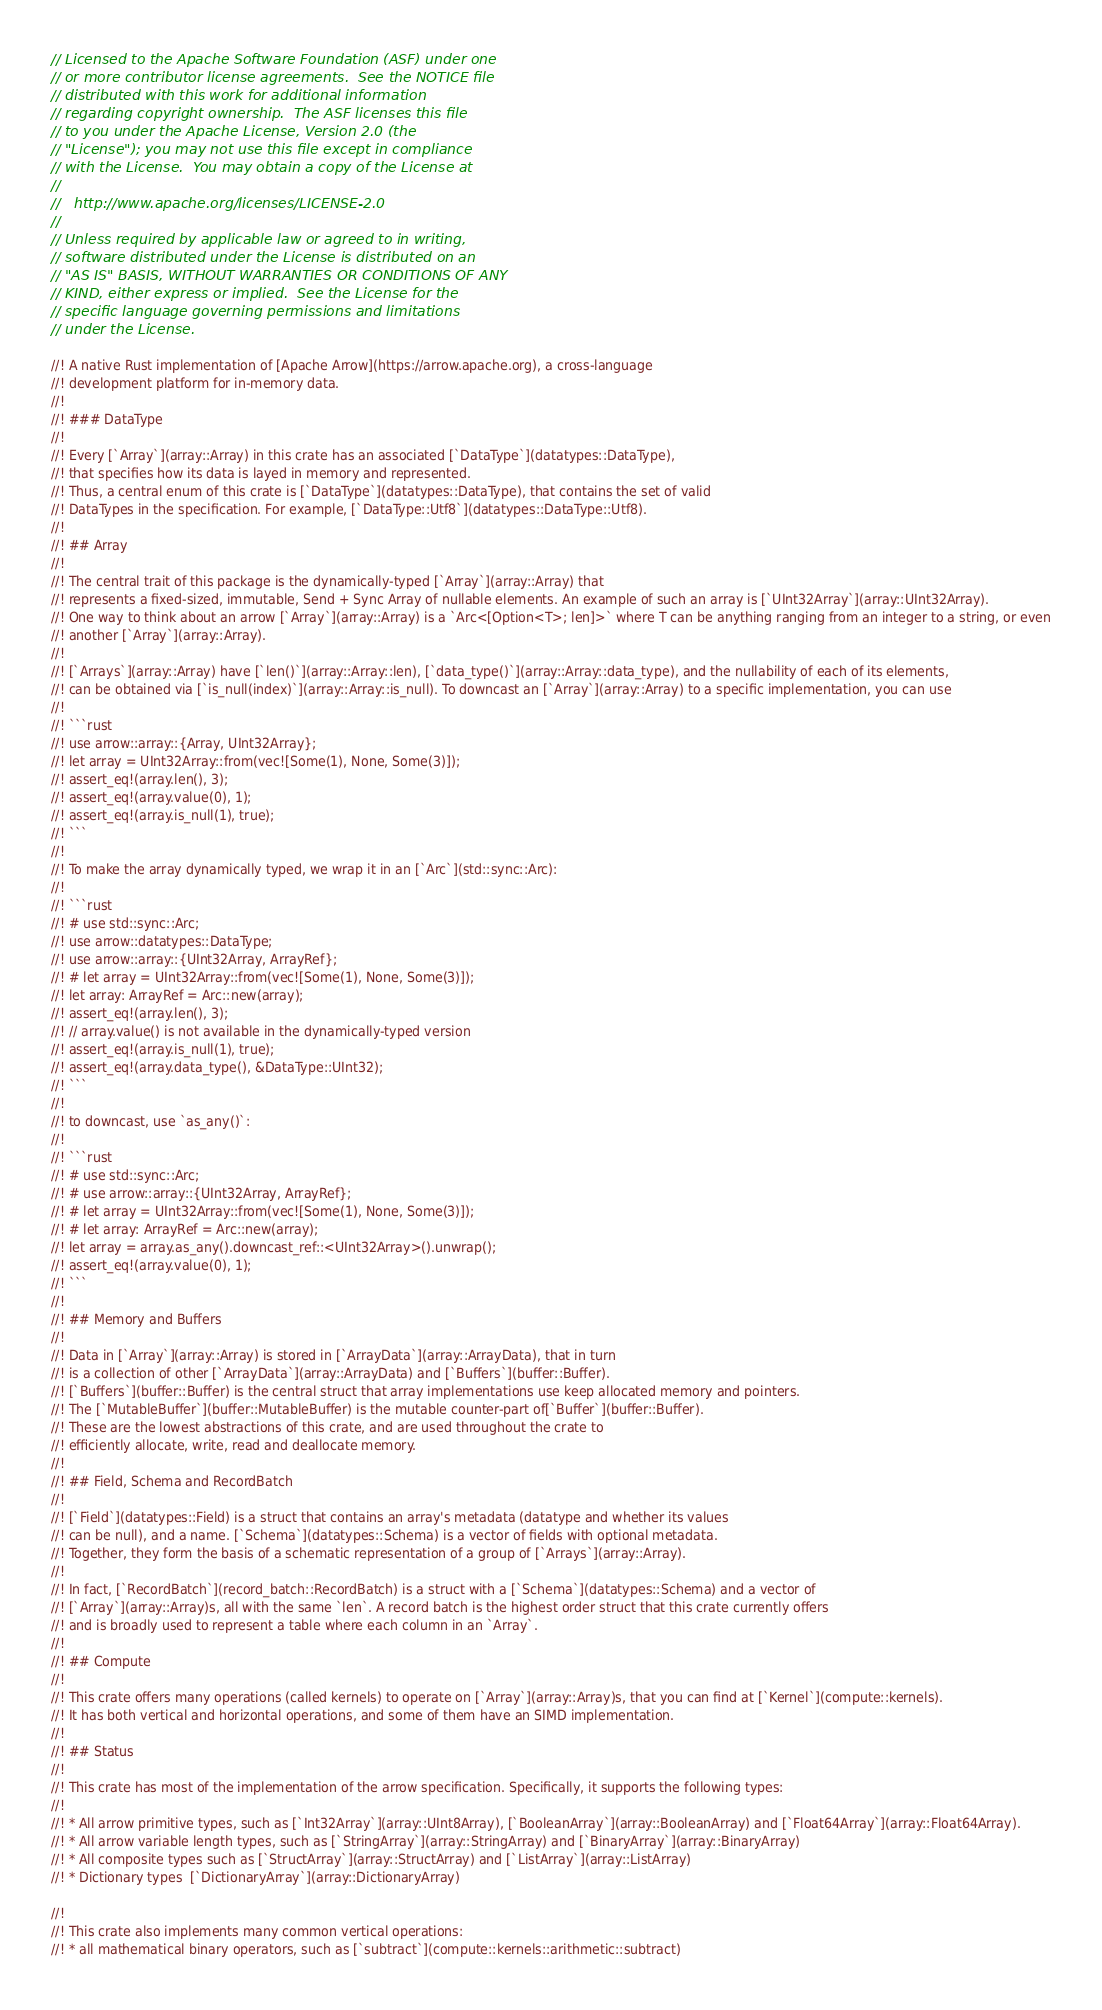Convert code to text. <code><loc_0><loc_0><loc_500><loc_500><_Rust_>// Licensed to the Apache Software Foundation (ASF) under one
// or more contributor license agreements.  See the NOTICE file
// distributed with this work for additional information
// regarding copyright ownership.  The ASF licenses this file
// to you under the Apache License, Version 2.0 (the
// "License"); you may not use this file except in compliance
// with the License.  You may obtain a copy of the License at
//
//   http://www.apache.org/licenses/LICENSE-2.0
//
// Unless required by applicable law or agreed to in writing,
// software distributed under the License is distributed on an
// "AS IS" BASIS, WITHOUT WARRANTIES OR CONDITIONS OF ANY
// KIND, either express or implied.  See the License for the
// specific language governing permissions and limitations
// under the License.

//! A native Rust implementation of [Apache Arrow](https://arrow.apache.org), a cross-language
//! development platform for in-memory data.
//!
//! ### DataType
//!
//! Every [`Array`](array::Array) in this crate has an associated [`DataType`](datatypes::DataType),
//! that specifies how its data is layed in memory and represented.
//! Thus, a central enum of this crate is [`DataType`](datatypes::DataType), that contains the set of valid
//! DataTypes in the specification. For example, [`DataType::Utf8`](datatypes::DataType::Utf8).
//!
//! ## Array
//!
//! The central trait of this package is the dynamically-typed [`Array`](array::Array) that
//! represents a fixed-sized, immutable, Send + Sync Array of nullable elements. An example of such an array is [`UInt32Array`](array::UInt32Array).
//! One way to think about an arrow [`Array`](array::Array) is a `Arc<[Option<T>; len]>` where T can be anything ranging from an integer to a string, or even
//! another [`Array`](array::Array).
//!
//! [`Arrays`](array::Array) have [`len()`](array::Array::len), [`data_type()`](array::Array::data_type), and the nullability of each of its elements,
//! can be obtained via [`is_null(index)`](array::Array::is_null). To downcast an [`Array`](array::Array) to a specific implementation, you can use
//!
//! ```rust
//! use arrow::array::{Array, UInt32Array};
//! let array = UInt32Array::from(vec![Some(1), None, Some(3)]);
//! assert_eq!(array.len(), 3);
//! assert_eq!(array.value(0), 1);
//! assert_eq!(array.is_null(1), true);
//! ```
//!
//! To make the array dynamically typed, we wrap it in an [`Arc`](std::sync::Arc):
//!
//! ```rust
//! # use std::sync::Arc;
//! use arrow::datatypes::DataType;
//! use arrow::array::{UInt32Array, ArrayRef};
//! # let array = UInt32Array::from(vec![Some(1), None, Some(3)]);
//! let array: ArrayRef = Arc::new(array);
//! assert_eq!(array.len(), 3);
//! // array.value() is not available in the dynamically-typed version
//! assert_eq!(array.is_null(1), true);
//! assert_eq!(array.data_type(), &DataType::UInt32);
//! ```
//!
//! to downcast, use `as_any()`:
//!
//! ```rust
//! # use std::sync::Arc;
//! # use arrow::array::{UInt32Array, ArrayRef};
//! # let array = UInt32Array::from(vec![Some(1), None, Some(3)]);
//! # let array: ArrayRef = Arc::new(array);
//! let array = array.as_any().downcast_ref::<UInt32Array>().unwrap();
//! assert_eq!(array.value(0), 1);
//! ```
//!
//! ## Memory and Buffers
//!
//! Data in [`Array`](array::Array) is stored in [`ArrayData`](array::ArrayData), that in turn
//! is a collection of other [`ArrayData`](array::ArrayData) and [`Buffers`](buffer::Buffer).
//! [`Buffers`](buffer::Buffer) is the central struct that array implementations use keep allocated memory and pointers.
//! The [`MutableBuffer`](buffer::MutableBuffer) is the mutable counter-part of[`Buffer`](buffer::Buffer).
//! These are the lowest abstractions of this crate, and are used throughout the crate to
//! efficiently allocate, write, read and deallocate memory.
//!
//! ## Field, Schema and RecordBatch
//!
//! [`Field`](datatypes::Field) is a struct that contains an array's metadata (datatype and whether its values
//! can be null), and a name. [`Schema`](datatypes::Schema) is a vector of fields with optional metadata.
//! Together, they form the basis of a schematic representation of a group of [`Arrays`](array::Array).
//!
//! In fact, [`RecordBatch`](record_batch::RecordBatch) is a struct with a [`Schema`](datatypes::Schema) and a vector of
//! [`Array`](array::Array)s, all with the same `len`. A record batch is the highest order struct that this crate currently offers
//! and is broadly used to represent a table where each column in an `Array`.
//!
//! ## Compute
//!
//! This crate offers many operations (called kernels) to operate on [`Array`](array::Array)s, that you can find at [`Kernel`](compute::kernels).
//! It has both vertical and horizontal operations, and some of them have an SIMD implementation.
//!
//! ## Status
//!
//! This crate has most of the implementation of the arrow specification. Specifically, it supports the following types:
//!
//! * All arrow primitive types, such as [`Int32Array`](array::UInt8Array), [`BooleanArray`](array::BooleanArray) and [`Float64Array`](array::Float64Array).
//! * All arrow variable length types, such as [`StringArray`](array::StringArray) and [`BinaryArray`](array::BinaryArray)
//! * All composite types such as [`StructArray`](array::StructArray) and [`ListArray`](array::ListArray)
//! * Dictionary types  [`DictionaryArray`](array::DictionaryArray)

//!
//! This crate also implements many common vertical operations:
//! * all mathematical binary operators, such as [`subtract`](compute::kernels::arithmetic::subtract)</code> 